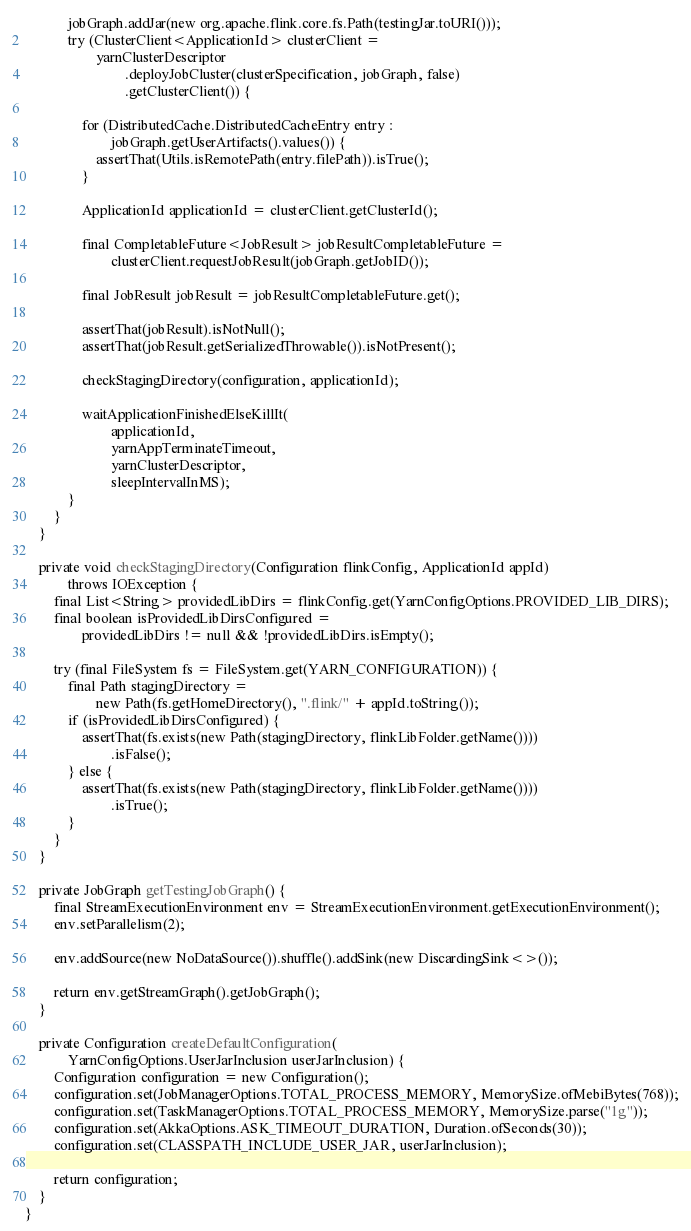Convert code to text. <code><loc_0><loc_0><loc_500><loc_500><_Java_>
            jobGraph.addJar(new org.apache.flink.core.fs.Path(testingJar.toURI()));
            try (ClusterClient<ApplicationId> clusterClient =
                    yarnClusterDescriptor
                            .deployJobCluster(clusterSpecification, jobGraph, false)
                            .getClusterClient()) {

                for (DistributedCache.DistributedCacheEntry entry :
                        jobGraph.getUserArtifacts().values()) {
                    assertThat(Utils.isRemotePath(entry.filePath)).isTrue();
                }

                ApplicationId applicationId = clusterClient.getClusterId();

                final CompletableFuture<JobResult> jobResultCompletableFuture =
                        clusterClient.requestJobResult(jobGraph.getJobID());

                final JobResult jobResult = jobResultCompletableFuture.get();

                assertThat(jobResult).isNotNull();
                assertThat(jobResult.getSerializedThrowable()).isNotPresent();

                checkStagingDirectory(configuration, applicationId);

                waitApplicationFinishedElseKillIt(
                        applicationId,
                        yarnAppTerminateTimeout,
                        yarnClusterDescriptor,
                        sleepIntervalInMS);
            }
        }
    }

    private void checkStagingDirectory(Configuration flinkConfig, ApplicationId appId)
            throws IOException {
        final List<String> providedLibDirs = flinkConfig.get(YarnConfigOptions.PROVIDED_LIB_DIRS);
        final boolean isProvidedLibDirsConfigured =
                providedLibDirs != null && !providedLibDirs.isEmpty();

        try (final FileSystem fs = FileSystem.get(YARN_CONFIGURATION)) {
            final Path stagingDirectory =
                    new Path(fs.getHomeDirectory(), ".flink/" + appId.toString());
            if (isProvidedLibDirsConfigured) {
                assertThat(fs.exists(new Path(stagingDirectory, flinkLibFolder.getName())))
                        .isFalse();
            } else {
                assertThat(fs.exists(new Path(stagingDirectory, flinkLibFolder.getName())))
                        .isTrue();
            }
        }
    }

    private JobGraph getTestingJobGraph() {
        final StreamExecutionEnvironment env = StreamExecutionEnvironment.getExecutionEnvironment();
        env.setParallelism(2);

        env.addSource(new NoDataSource()).shuffle().addSink(new DiscardingSink<>());

        return env.getStreamGraph().getJobGraph();
    }

    private Configuration createDefaultConfiguration(
            YarnConfigOptions.UserJarInclusion userJarInclusion) {
        Configuration configuration = new Configuration();
        configuration.set(JobManagerOptions.TOTAL_PROCESS_MEMORY, MemorySize.ofMebiBytes(768));
        configuration.set(TaskManagerOptions.TOTAL_PROCESS_MEMORY, MemorySize.parse("1g"));
        configuration.set(AkkaOptions.ASK_TIMEOUT_DURATION, Duration.ofSeconds(30));
        configuration.set(CLASSPATH_INCLUDE_USER_JAR, userJarInclusion);

        return configuration;
    }
}
</code> 